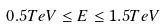<formula> <loc_0><loc_0><loc_500><loc_500>0 . 5 T e V \leq E \leq 1 . 5 T e V</formula> 